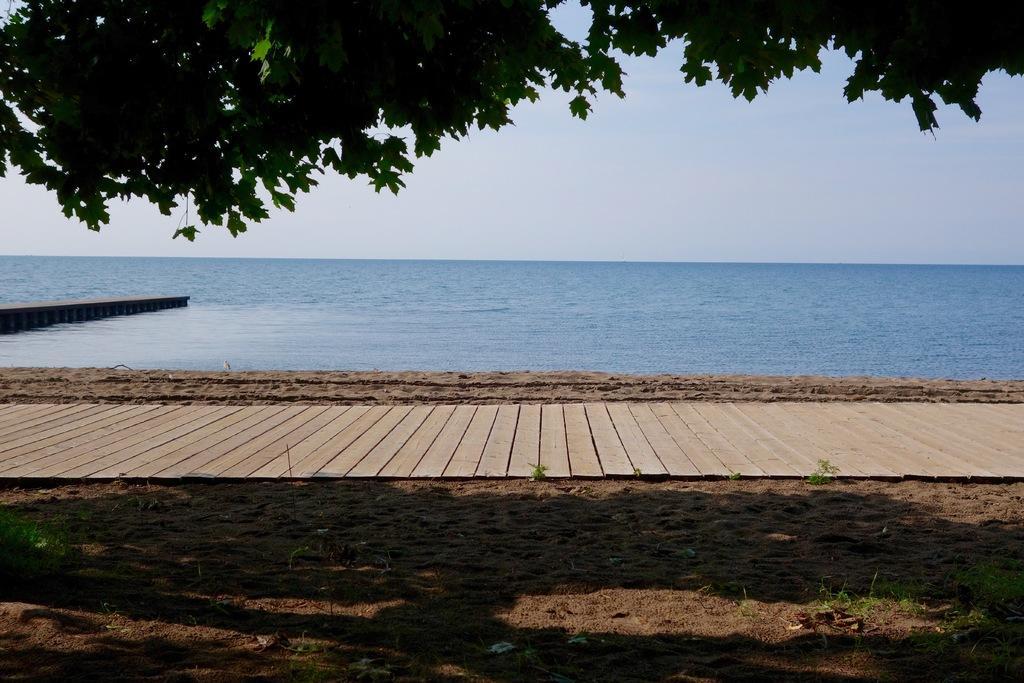In one or two sentences, can you explain what this image depicts? In this image I can see few trees in green color and I can also see water and sky in blue color. 